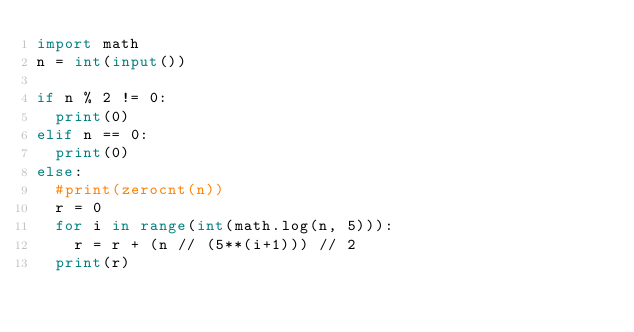<code> <loc_0><loc_0><loc_500><loc_500><_Python_>import math
n = int(input())

if n % 2 != 0:
  print(0)
elif n == 0:
  print(0)
else:
  #print(zerocnt(n))
  r = 0
  for i in range(int(math.log(n, 5))):
    r = r + (n // (5**(i+1))) // 2
  print(r)</code> 